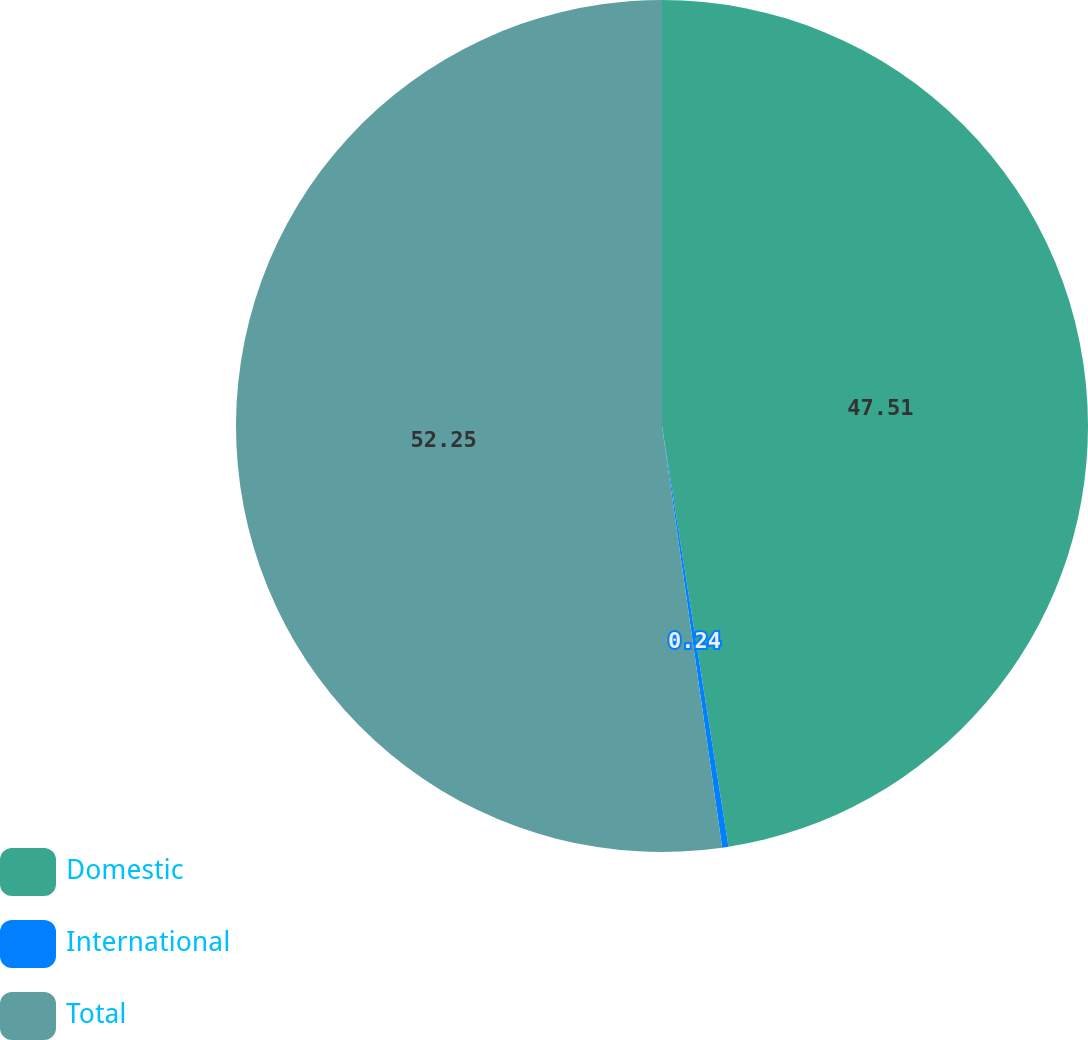<chart> <loc_0><loc_0><loc_500><loc_500><pie_chart><fcel>Domestic<fcel>International<fcel>Total<nl><fcel>47.51%<fcel>0.24%<fcel>52.26%<nl></chart> 